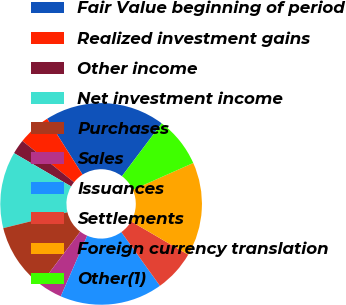<chart> <loc_0><loc_0><loc_500><loc_500><pie_chart><fcel>Fair Value beginning of period<fcel>Realized investment gains<fcel>Other income<fcel>Net investment income<fcel>Purchases<fcel>Sales<fcel>Issuances<fcel>Settlements<fcel>Foreign currency translation<fcel>Other(1)<nl><fcel>19.25%<fcel>5.28%<fcel>2.33%<fcel>12.27%<fcel>10.87%<fcel>3.72%<fcel>16.46%<fcel>6.68%<fcel>15.06%<fcel>8.08%<nl></chart> 